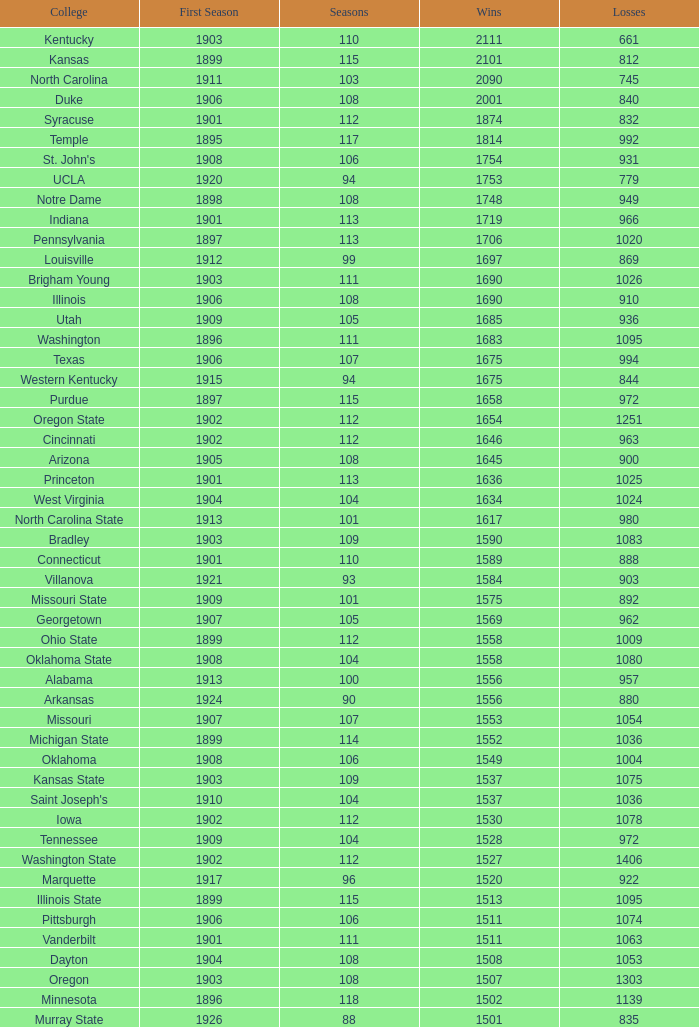With losses exceeding 980, a first season commencing before 1906, and a rank surpassing 42, what was the total number of wins for washington state college? 0.0. 